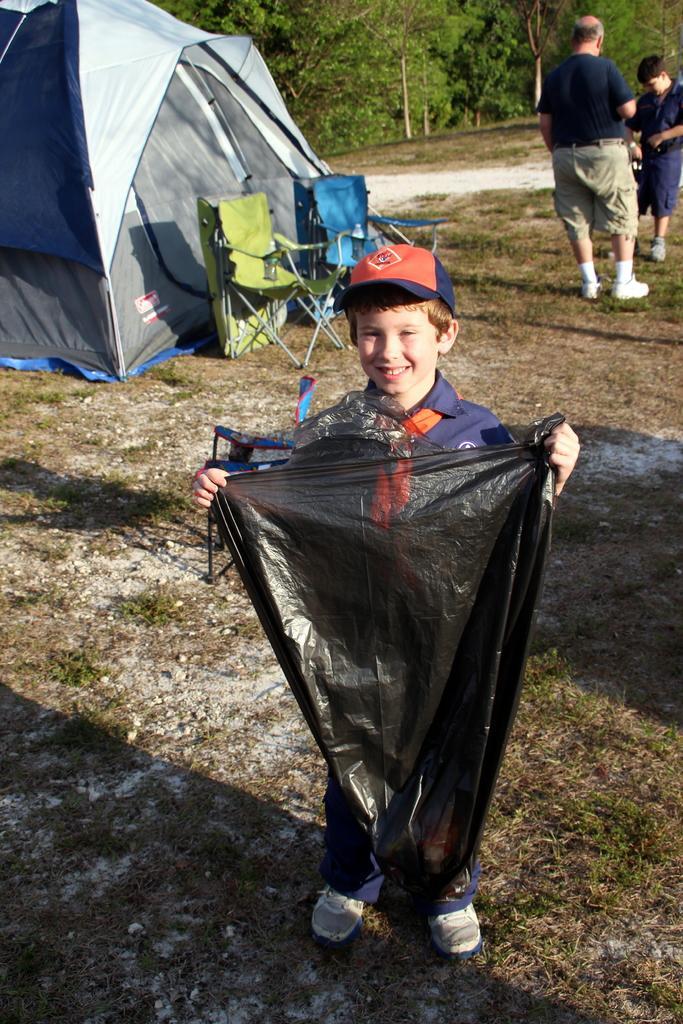Please provide a concise description of this image. In this image in the foreground there is one boy who is standing and smiling and he is holding one plastic cover, and in the background there are two persons who are standing and on the left side there is one tent and two chairs and there are some trees. At the bottom there is grass. 